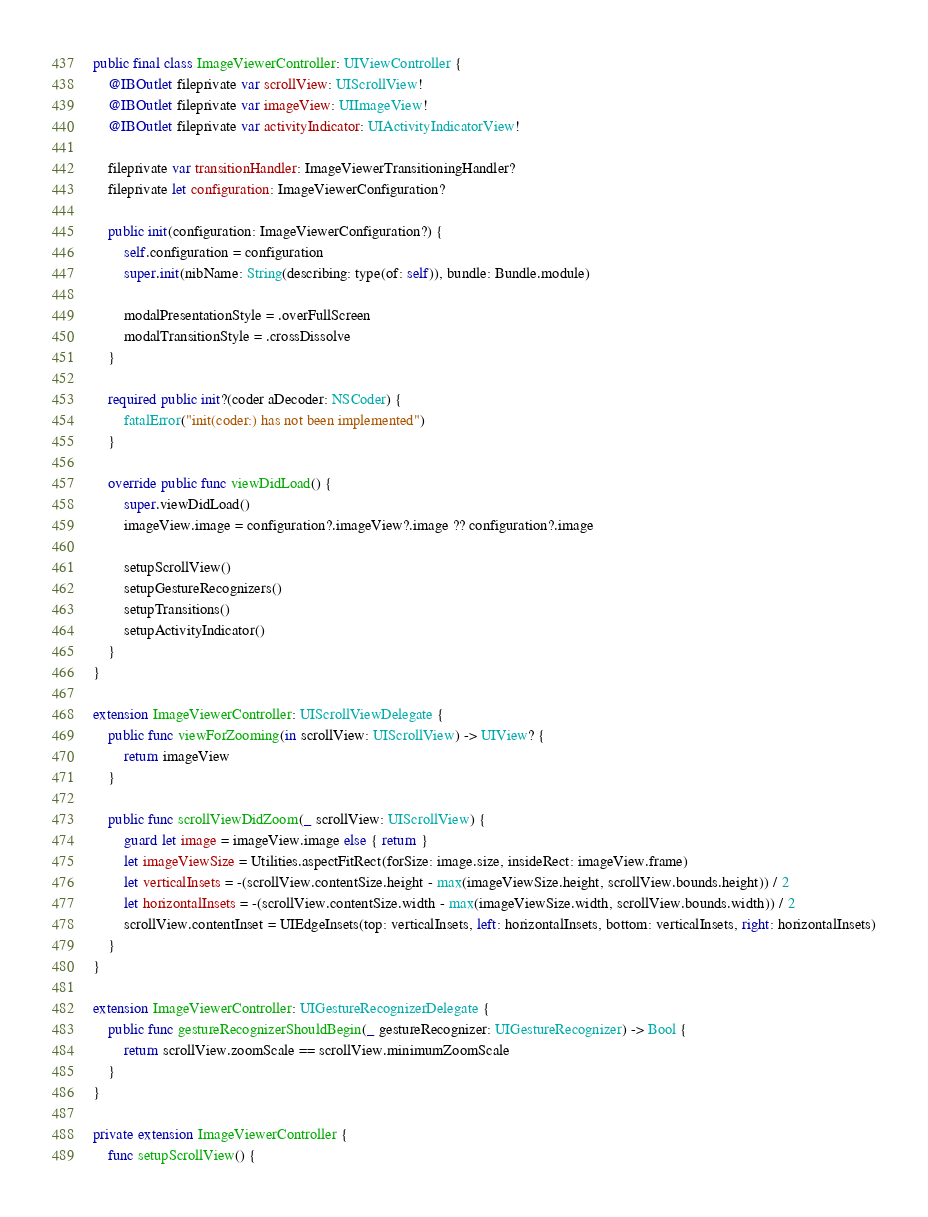Convert code to text. <code><loc_0><loc_0><loc_500><loc_500><_Swift_>
public final class ImageViewerController: UIViewController {
    @IBOutlet fileprivate var scrollView: UIScrollView!
    @IBOutlet fileprivate var imageView: UIImageView!
    @IBOutlet fileprivate var activityIndicator: UIActivityIndicatorView!
    
    fileprivate var transitionHandler: ImageViewerTransitioningHandler?
    fileprivate let configuration: ImageViewerConfiguration?
    
    public init(configuration: ImageViewerConfiguration?) {
        self.configuration = configuration
        super.init(nibName: String(describing: type(of: self)), bundle: Bundle.module)
        
        modalPresentationStyle = .overFullScreen
        modalTransitionStyle = .crossDissolve
    }
    
    required public init?(coder aDecoder: NSCoder) {
        fatalError("init(coder:) has not been implemented")
    }
    
    override public func viewDidLoad() {
        super.viewDidLoad()
        imageView.image = configuration?.imageView?.image ?? configuration?.image
        
        setupScrollView()
        setupGestureRecognizers()
        setupTransitions()
        setupActivityIndicator()
    }
}

extension ImageViewerController: UIScrollViewDelegate {
    public func viewForZooming(in scrollView: UIScrollView) -> UIView? {
        return imageView
    }
    
    public func scrollViewDidZoom(_ scrollView: UIScrollView) {
        guard let image = imageView.image else { return }
        let imageViewSize = Utilities.aspectFitRect(forSize: image.size, insideRect: imageView.frame)
        let verticalInsets = -(scrollView.contentSize.height - max(imageViewSize.height, scrollView.bounds.height)) / 2
        let horizontalInsets = -(scrollView.contentSize.width - max(imageViewSize.width, scrollView.bounds.width)) / 2
        scrollView.contentInset = UIEdgeInsets(top: verticalInsets, left: horizontalInsets, bottom: verticalInsets, right: horizontalInsets)
    }
}

extension ImageViewerController: UIGestureRecognizerDelegate {
    public func gestureRecognizerShouldBegin(_ gestureRecognizer: UIGestureRecognizer) -> Bool {
        return scrollView.zoomScale == scrollView.minimumZoomScale
    }
}

private extension ImageViewerController {
    func setupScrollView() {</code> 